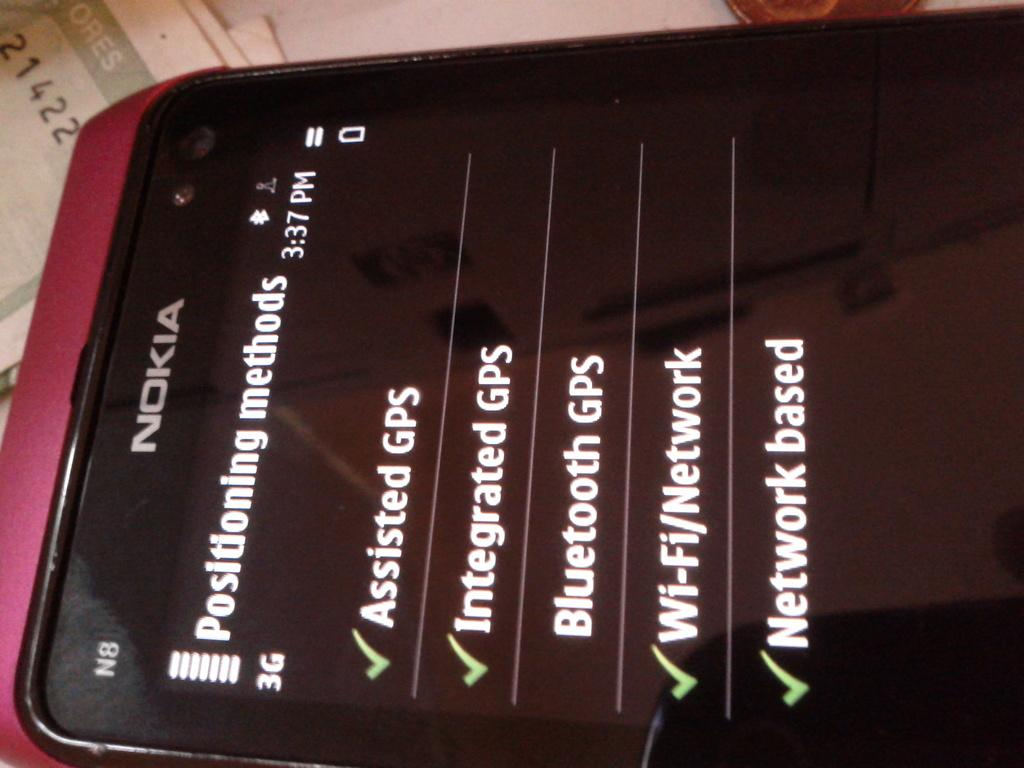<image>
Summarize the visual content of the image. A checklist is displayed on the screen of a Nokia phone. 